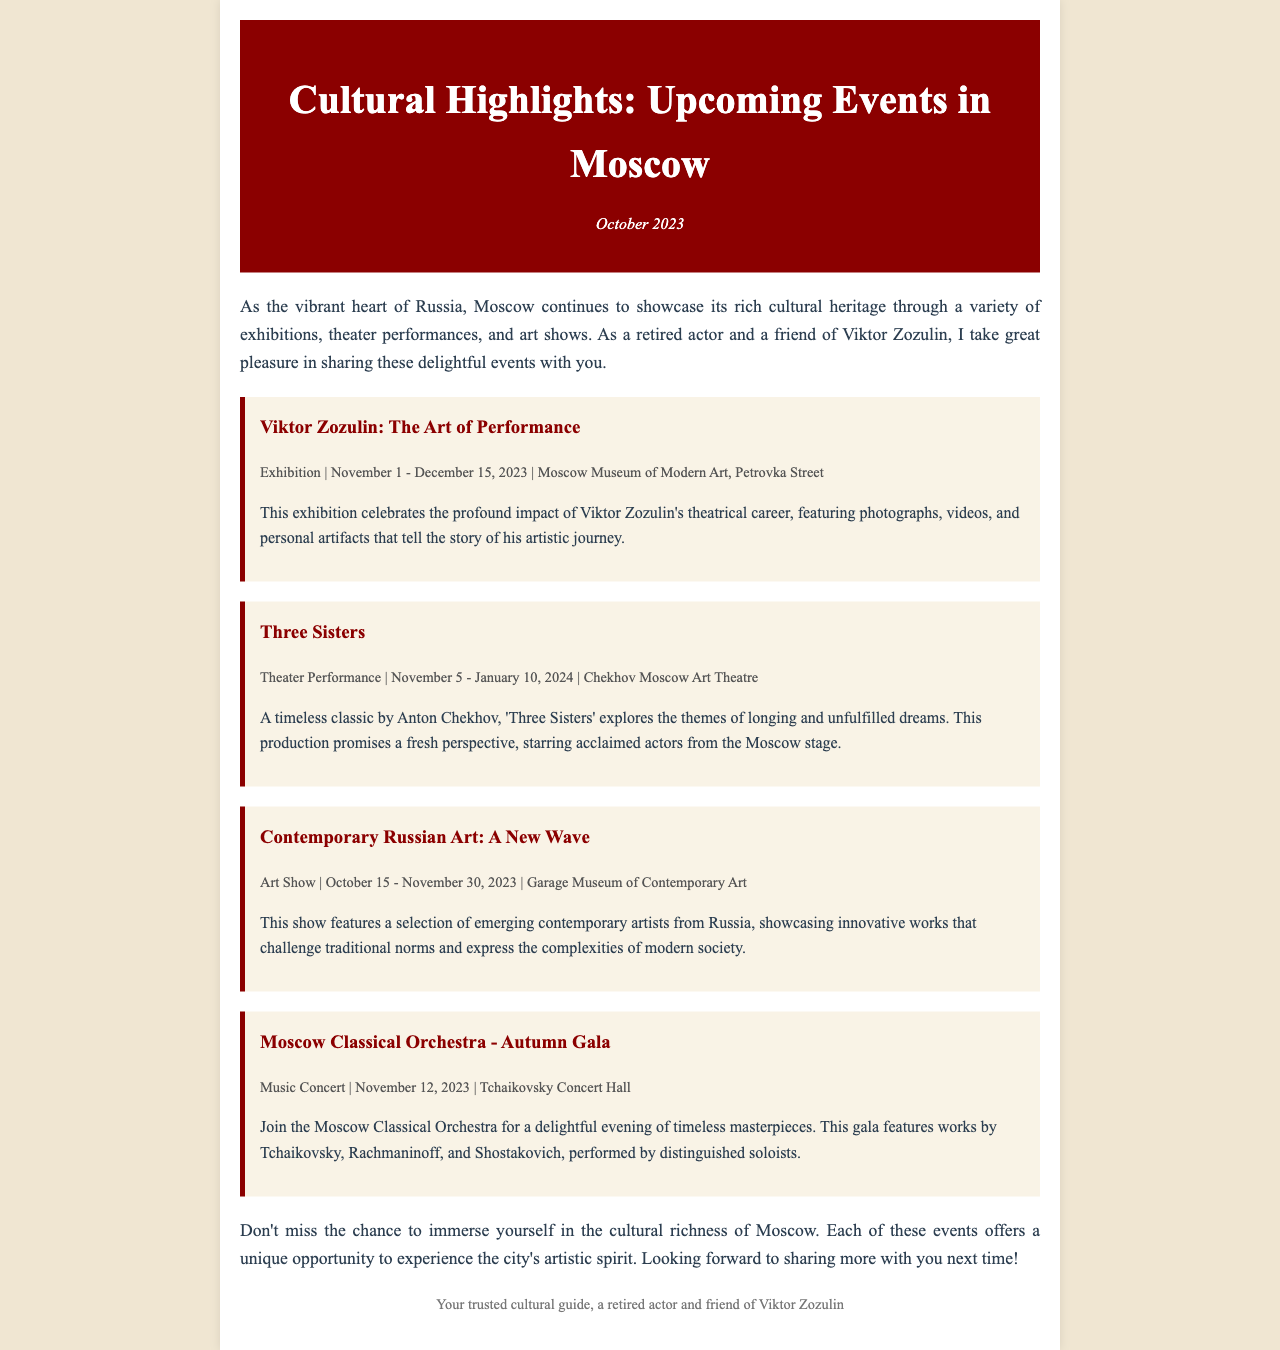What is the title of Viktor Zozulin's exhibition? The title of the exhibition is explicitly stated in the document.
Answer: The Art of Performance What are the dates for the theater performance "Three Sisters"? The specific dates for the performance can be found in the event details section.
Answer: November 5 - January 10, 2024 Where will the "Contemporary Russian Art: A New Wave" show be held? The location of the art show is provided in the document.
Answer: Garage Museum of Contemporary Art Which orchestral works will be featured in the Autumn Gala? The document lists the composers whose works will be performed during the gala.
Answer: Tchaikovsky, Rachmaninoff, and Shostakovich What type of event is "Viktor Zozulin: The Art of Performance"? The document specifies the nature of the event and categorizes it.
Answer: Exhibition How many events are mentioned in the newsletter? By counting, we can determine the total number of distinct events listed.
Answer: Four What is the main theme of "Three Sisters"? The document describes the thematic focus of the performance.
Answer: Longing and unfulfilled dreams What is the main purpose of the newsletter? The newsletter explains its intent in the introductory paragraph.
Answer: To showcase cultural events in Moscow 